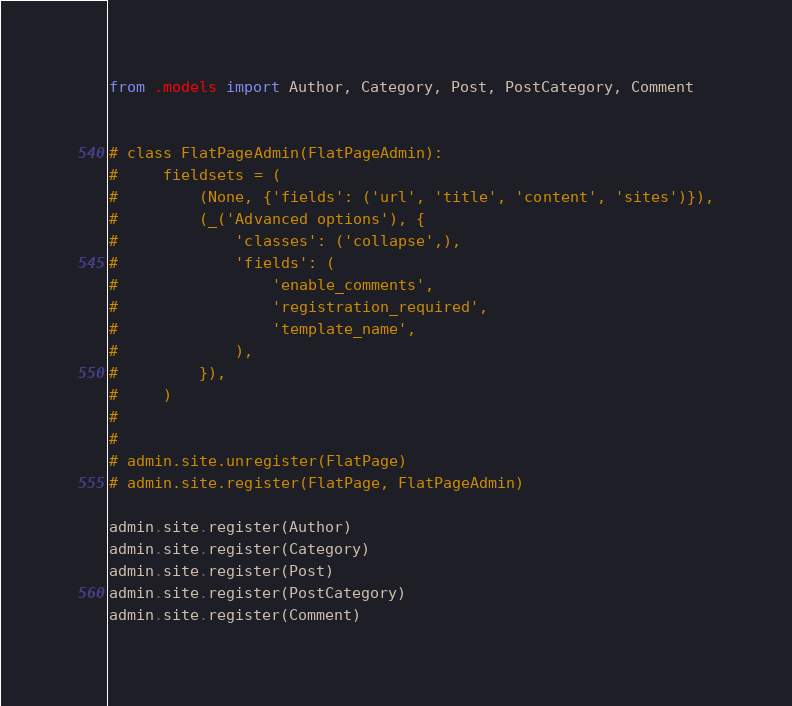Convert code to text. <code><loc_0><loc_0><loc_500><loc_500><_Python_>from .models import Author, Category, Post, PostCategory, Comment


# class FlatPageAdmin(FlatPageAdmin):
#     fieldsets = (
#         (None, {'fields': ('url', 'title', 'content', 'sites')}),
#         (_('Advanced options'), {
#             'classes': ('collapse',),
#             'fields': (
#                 'enable_comments',
#                 'registration_required',
#                 'template_name',
#             ),
#         }),
#     )
#
#
# admin.site.unregister(FlatPage)
# admin.site.register(FlatPage, FlatPageAdmin)

admin.site.register(Author)
admin.site.register(Category)
admin.site.register(Post)
admin.site.register(PostCategory)
admin.site.register(Comment)
</code> 